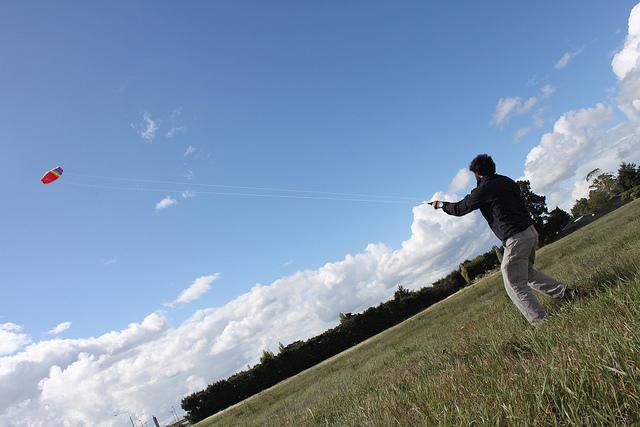Is the man practicing a dangerous sport?
Be succinct. No. What is the man holding?
Answer briefly. Kite. What is this sport?
Quick response, please. Kiting. How many kites are there?
Quick response, please. 1. What is the man wearing on his feet?
Be succinct. Shoes. Is it cold out?
Quick response, please. Yes. Is there a lot of snow on the floor?
Give a very brief answer. No. What color shirt is he wearing?
Answer briefly. Black. What are the horses doing on the hill?
Quick response, please. There are no horses. Are all three people in the air?
Short answer required. No. Is the man on the ground?
Keep it brief. Yes. What is the dog doing?
Write a very short answer. No dog. What is this person doing?
Give a very brief answer. Flying kite. What color other than white is seen on the ground?
Give a very brief answer. Green. Where is he facing?
Short answer required. Kite. Is the terrain flat?
Keep it brief. Yes. Is there a fence?
Give a very brief answer. No. Are these large kites or small kites?
Write a very short answer. Large. What is the person standing o?
Write a very short answer. Grass. What is the location of the man?
Short answer required. Field. Are these mountain climbers?
Write a very short answer. No. Are they on a mountain?
Keep it brief. No. Is the man doing a trick?
Concise answer only. No. What season is this?
Keep it brief. Spring. What season is it?
Quick response, please. Spring. Where is the man's right leg?
Short answer required. On ground. What is the terrain?
Write a very short answer. Grass. Is the man a father?
Concise answer only. No. What color coat are they wearing?
Short answer required. Black. Could the season be winter?
Be succinct. Yes. Where is this taken place?
Give a very brief answer. Field. How many hands is the man holding the kite with?
Concise answer only. 1. Is the man wearing a helmet?
Short answer required. No. Is this photo recent?
Concise answer only. Yes. Is there snow?
Keep it brief. No. What color is the man's shirt?
Keep it brief. Black. What sport is this?
Give a very brief answer. Kite flying. Is he snowboarding?
Give a very brief answer. No. How many clouds are in the sky?
Short answer required. Many. Would you expect to see this in Florida?
Answer briefly. Yes. Why is the person raising his arms?
Be succinct. Flying kite. Can you see any unfrozen water?
Write a very short answer. No. Is he wearing a hat?
Answer briefly. No. What sport is this person participating in?
Write a very short answer. Kite flying. What color is the person's pants?
Write a very short answer. Tan. Are there clouds in the sky?
Quick response, please. Yes. Is what the man is doing dangerous?
Concise answer only. No. Is someone airborne?
Concise answer only. No. What is the person doing?
Write a very short answer. Flying kite. What is on the ground?
Concise answer only. Grass. Where is this picture taken?
Write a very short answer. Field. What color is the frisbee?
Concise answer only. Red. Is sand flying?
Write a very short answer. No. Is this guy jumping over the?
Concise answer only. No. What is he holding onto?
Keep it brief. Kite. 